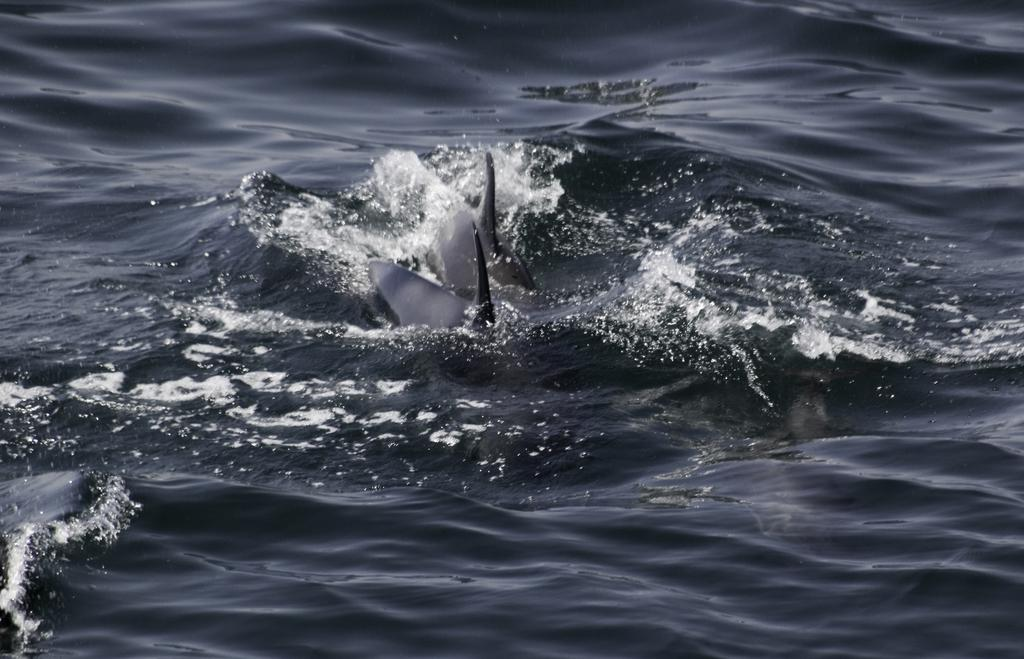Where was the image taken? The image was taken outdoors. What can be seen at the bottom of the image? There is a sea at the bottom of the image. What animals are present in the sea in the middle of the image? There are two sharks in the sea in the middle of the image. What type of protest is taking place near the sharks in the image? There is no protest present in the image. 